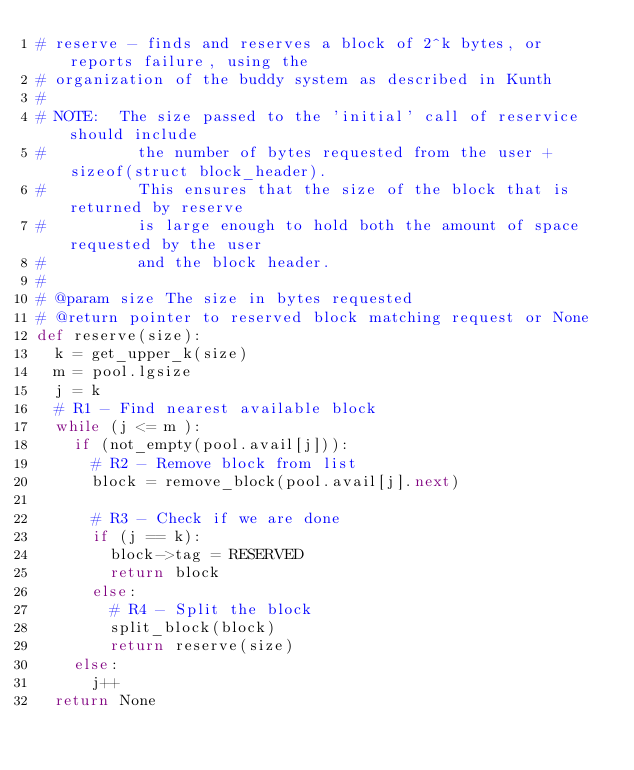<code> <loc_0><loc_0><loc_500><loc_500><_Python_># reserve - finds and reserves a block of 2^k bytes, or reports failure, using the
# organization of the buddy system as described in Kunth
#
# NOTE:  The size passed to the 'initial' call of reservice should include
#          the number of bytes requested from the user + sizeof(struct block_header).
#          This ensures that the size of the block that is returned by reserve
#          is large enough to hold both the amount of space requested by the user
#          and the block header.
#
# @param size The size in bytes requested
# @return pointer to reserved block matching request or None
def reserve(size):
	k = get_upper_k(size)
	m = pool.lgsize
	j = k
	# R1 - Find nearest available block
	while (j <= m ):
		if (not_empty(pool.avail[j])):
			# R2 - Remove block from list
			block = remove_block(pool.avail[j].next)

			# R3 - Check if we are done
			if (j == k):
				block->tag = RESERVED
				return block
			else:
				# R4 - Split the block
				split_block(block)
				return reserve(size)
		else:
			j++	
	return None

</code> 